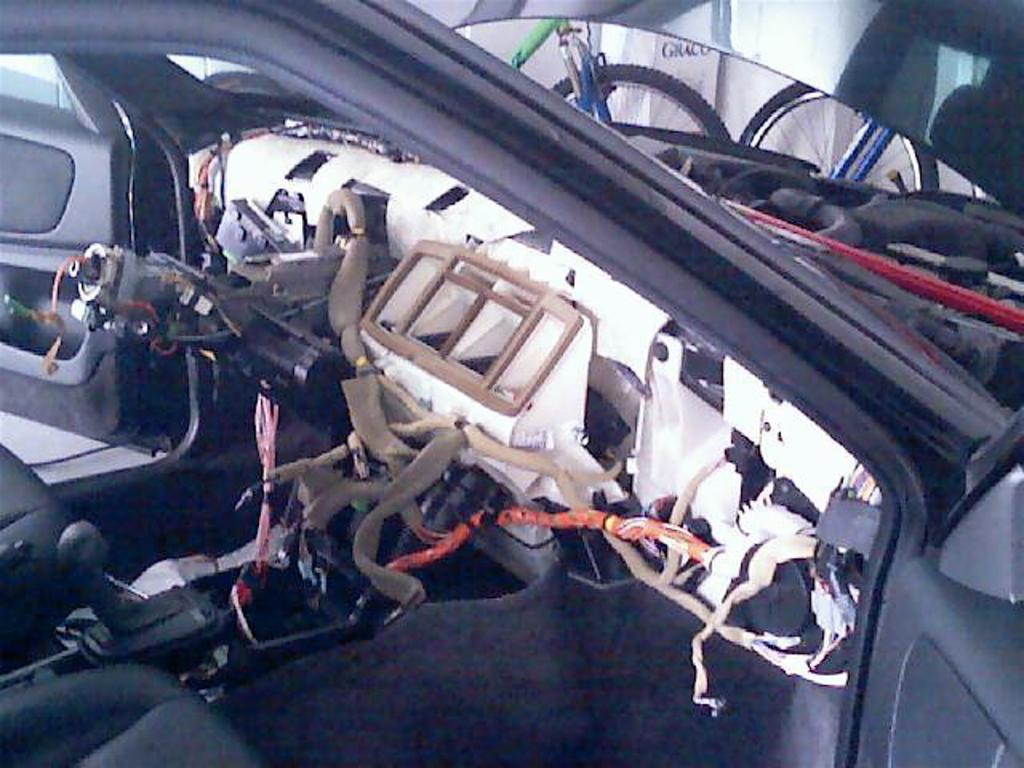What type of setting is depicted in the image? The image is an inside view of a car. Can you describe any specific features or objects visible in the car? Unfortunately, the provided facts do not mention any specific features or objects visible in the car. What type of trousers is the driver wearing in the image? There is no driver visible in the image, and therefore no information about the driver's trousers can be provided. What brand of soda can be seen in the image? There is no soda present in the image. Is there a toothbrush visible in the image? There is no toothbrush present in the image. 